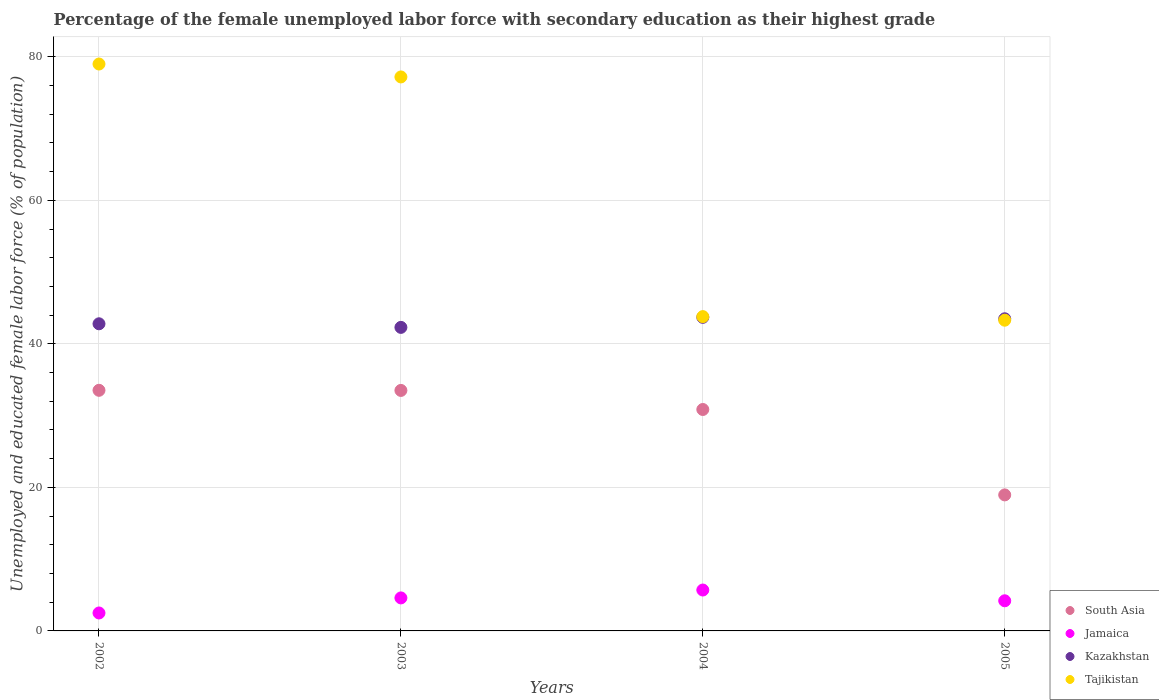How many different coloured dotlines are there?
Your response must be concise. 4. What is the percentage of the unemployed female labor force with secondary education in South Asia in 2003?
Offer a terse response. 33.51. Across all years, what is the maximum percentage of the unemployed female labor force with secondary education in Kazakhstan?
Make the answer very short. 43.7. Across all years, what is the minimum percentage of the unemployed female labor force with secondary education in Tajikistan?
Provide a succinct answer. 43.3. In which year was the percentage of the unemployed female labor force with secondary education in Kazakhstan maximum?
Offer a very short reply. 2004. In which year was the percentage of the unemployed female labor force with secondary education in Tajikistan minimum?
Give a very brief answer. 2005. What is the total percentage of the unemployed female labor force with secondary education in Tajikistan in the graph?
Your answer should be compact. 243.3. What is the difference between the percentage of the unemployed female labor force with secondary education in Jamaica in 2004 and the percentage of the unemployed female labor force with secondary education in Tajikistan in 2005?
Your response must be concise. -37.6. What is the average percentage of the unemployed female labor force with secondary education in Kazakhstan per year?
Your response must be concise. 43.07. In the year 2002, what is the difference between the percentage of the unemployed female labor force with secondary education in South Asia and percentage of the unemployed female labor force with secondary education in Jamaica?
Keep it short and to the point. 31.03. What is the ratio of the percentage of the unemployed female labor force with secondary education in South Asia in 2002 to that in 2004?
Keep it short and to the point. 1.09. What is the difference between the highest and the second highest percentage of the unemployed female labor force with secondary education in Kazakhstan?
Offer a very short reply. 0.2. What is the difference between the highest and the lowest percentage of the unemployed female labor force with secondary education in Tajikistan?
Offer a terse response. 35.7. In how many years, is the percentage of the unemployed female labor force with secondary education in South Asia greater than the average percentage of the unemployed female labor force with secondary education in South Asia taken over all years?
Give a very brief answer. 3. Is it the case that in every year, the sum of the percentage of the unemployed female labor force with secondary education in Tajikistan and percentage of the unemployed female labor force with secondary education in Jamaica  is greater than the sum of percentage of the unemployed female labor force with secondary education in Kazakhstan and percentage of the unemployed female labor force with secondary education in South Asia?
Give a very brief answer. Yes. Is it the case that in every year, the sum of the percentage of the unemployed female labor force with secondary education in Jamaica and percentage of the unemployed female labor force with secondary education in South Asia  is greater than the percentage of the unemployed female labor force with secondary education in Kazakhstan?
Make the answer very short. No. Does the percentage of the unemployed female labor force with secondary education in Jamaica monotonically increase over the years?
Keep it short and to the point. No. How many years are there in the graph?
Provide a short and direct response. 4. Are the values on the major ticks of Y-axis written in scientific E-notation?
Provide a short and direct response. No. How are the legend labels stacked?
Provide a succinct answer. Vertical. What is the title of the graph?
Make the answer very short. Percentage of the female unemployed labor force with secondary education as their highest grade. What is the label or title of the X-axis?
Your answer should be very brief. Years. What is the label or title of the Y-axis?
Make the answer very short. Unemployed and educated female labor force (% of population). What is the Unemployed and educated female labor force (% of population) in South Asia in 2002?
Provide a succinct answer. 33.53. What is the Unemployed and educated female labor force (% of population) in Jamaica in 2002?
Your response must be concise. 2.5. What is the Unemployed and educated female labor force (% of population) of Kazakhstan in 2002?
Keep it short and to the point. 42.8. What is the Unemployed and educated female labor force (% of population) of Tajikistan in 2002?
Your answer should be very brief. 79. What is the Unemployed and educated female labor force (% of population) of South Asia in 2003?
Keep it short and to the point. 33.51. What is the Unemployed and educated female labor force (% of population) in Jamaica in 2003?
Give a very brief answer. 4.6. What is the Unemployed and educated female labor force (% of population) in Kazakhstan in 2003?
Provide a succinct answer. 42.3. What is the Unemployed and educated female labor force (% of population) of Tajikistan in 2003?
Offer a very short reply. 77.2. What is the Unemployed and educated female labor force (% of population) in South Asia in 2004?
Ensure brevity in your answer.  30.86. What is the Unemployed and educated female labor force (% of population) in Jamaica in 2004?
Offer a terse response. 5.7. What is the Unemployed and educated female labor force (% of population) of Kazakhstan in 2004?
Your answer should be very brief. 43.7. What is the Unemployed and educated female labor force (% of population) of Tajikistan in 2004?
Your answer should be compact. 43.8. What is the Unemployed and educated female labor force (% of population) of South Asia in 2005?
Provide a short and direct response. 18.96. What is the Unemployed and educated female labor force (% of population) in Jamaica in 2005?
Give a very brief answer. 4.2. What is the Unemployed and educated female labor force (% of population) in Kazakhstan in 2005?
Offer a terse response. 43.5. What is the Unemployed and educated female labor force (% of population) of Tajikistan in 2005?
Your answer should be very brief. 43.3. Across all years, what is the maximum Unemployed and educated female labor force (% of population) in South Asia?
Your response must be concise. 33.53. Across all years, what is the maximum Unemployed and educated female labor force (% of population) in Jamaica?
Offer a terse response. 5.7. Across all years, what is the maximum Unemployed and educated female labor force (% of population) in Kazakhstan?
Provide a short and direct response. 43.7. Across all years, what is the maximum Unemployed and educated female labor force (% of population) in Tajikistan?
Keep it short and to the point. 79. Across all years, what is the minimum Unemployed and educated female labor force (% of population) of South Asia?
Offer a terse response. 18.96. Across all years, what is the minimum Unemployed and educated female labor force (% of population) in Kazakhstan?
Make the answer very short. 42.3. Across all years, what is the minimum Unemployed and educated female labor force (% of population) in Tajikistan?
Provide a succinct answer. 43.3. What is the total Unemployed and educated female labor force (% of population) of South Asia in the graph?
Provide a short and direct response. 116.86. What is the total Unemployed and educated female labor force (% of population) of Kazakhstan in the graph?
Provide a succinct answer. 172.3. What is the total Unemployed and educated female labor force (% of population) of Tajikistan in the graph?
Provide a succinct answer. 243.3. What is the difference between the Unemployed and educated female labor force (% of population) in South Asia in 2002 and that in 2003?
Offer a terse response. 0.02. What is the difference between the Unemployed and educated female labor force (% of population) in Jamaica in 2002 and that in 2003?
Your answer should be very brief. -2.1. What is the difference between the Unemployed and educated female labor force (% of population) in South Asia in 2002 and that in 2004?
Provide a succinct answer. 2.67. What is the difference between the Unemployed and educated female labor force (% of population) in Kazakhstan in 2002 and that in 2004?
Your answer should be compact. -0.9. What is the difference between the Unemployed and educated female labor force (% of population) in Tajikistan in 2002 and that in 2004?
Keep it short and to the point. 35.2. What is the difference between the Unemployed and educated female labor force (% of population) in South Asia in 2002 and that in 2005?
Your response must be concise. 14.58. What is the difference between the Unemployed and educated female labor force (% of population) in Jamaica in 2002 and that in 2005?
Your response must be concise. -1.7. What is the difference between the Unemployed and educated female labor force (% of population) of Tajikistan in 2002 and that in 2005?
Provide a succinct answer. 35.7. What is the difference between the Unemployed and educated female labor force (% of population) of South Asia in 2003 and that in 2004?
Your response must be concise. 2.66. What is the difference between the Unemployed and educated female labor force (% of population) of Tajikistan in 2003 and that in 2004?
Provide a succinct answer. 33.4. What is the difference between the Unemployed and educated female labor force (% of population) in South Asia in 2003 and that in 2005?
Your response must be concise. 14.56. What is the difference between the Unemployed and educated female labor force (% of population) of Jamaica in 2003 and that in 2005?
Your response must be concise. 0.4. What is the difference between the Unemployed and educated female labor force (% of population) of Tajikistan in 2003 and that in 2005?
Offer a terse response. 33.9. What is the difference between the Unemployed and educated female labor force (% of population) of South Asia in 2004 and that in 2005?
Your answer should be compact. 11.9. What is the difference between the Unemployed and educated female labor force (% of population) of Jamaica in 2004 and that in 2005?
Keep it short and to the point. 1.5. What is the difference between the Unemployed and educated female labor force (% of population) in Kazakhstan in 2004 and that in 2005?
Your response must be concise. 0.2. What is the difference between the Unemployed and educated female labor force (% of population) of South Asia in 2002 and the Unemployed and educated female labor force (% of population) of Jamaica in 2003?
Ensure brevity in your answer.  28.93. What is the difference between the Unemployed and educated female labor force (% of population) of South Asia in 2002 and the Unemployed and educated female labor force (% of population) of Kazakhstan in 2003?
Ensure brevity in your answer.  -8.77. What is the difference between the Unemployed and educated female labor force (% of population) of South Asia in 2002 and the Unemployed and educated female labor force (% of population) of Tajikistan in 2003?
Provide a succinct answer. -43.67. What is the difference between the Unemployed and educated female labor force (% of population) in Jamaica in 2002 and the Unemployed and educated female labor force (% of population) in Kazakhstan in 2003?
Your response must be concise. -39.8. What is the difference between the Unemployed and educated female labor force (% of population) in Jamaica in 2002 and the Unemployed and educated female labor force (% of population) in Tajikistan in 2003?
Your answer should be compact. -74.7. What is the difference between the Unemployed and educated female labor force (% of population) of Kazakhstan in 2002 and the Unemployed and educated female labor force (% of population) of Tajikistan in 2003?
Ensure brevity in your answer.  -34.4. What is the difference between the Unemployed and educated female labor force (% of population) in South Asia in 2002 and the Unemployed and educated female labor force (% of population) in Jamaica in 2004?
Your answer should be compact. 27.83. What is the difference between the Unemployed and educated female labor force (% of population) of South Asia in 2002 and the Unemployed and educated female labor force (% of population) of Kazakhstan in 2004?
Your answer should be compact. -10.17. What is the difference between the Unemployed and educated female labor force (% of population) of South Asia in 2002 and the Unemployed and educated female labor force (% of population) of Tajikistan in 2004?
Ensure brevity in your answer.  -10.27. What is the difference between the Unemployed and educated female labor force (% of population) in Jamaica in 2002 and the Unemployed and educated female labor force (% of population) in Kazakhstan in 2004?
Offer a very short reply. -41.2. What is the difference between the Unemployed and educated female labor force (% of population) of Jamaica in 2002 and the Unemployed and educated female labor force (% of population) of Tajikistan in 2004?
Offer a very short reply. -41.3. What is the difference between the Unemployed and educated female labor force (% of population) in South Asia in 2002 and the Unemployed and educated female labor force (% of population) in Jamaica in 2005?
Make the answer very short. 29.33. What is the difference between the Unemployed and educated female labor force (% of population) in South Asia in 2002 and the Unemployed and educated female labor force (% of population) in Kazakhstan in 2005?
Your response must be concise. -9.97. What is the difference between the Unemployed and educated female labor force (% of population) of South Asia in 2002 and the Unemployed and educated female labor force (% of population) of Tajikistan in 2005?
Your answer should be very brief. -9.77. What is the difference between the Unemployed and educated female labor force (% of population) in Jamaica in 2002 and the Unemployed and educated female labor force (% of population) in Kazakhstan in 2005?
Your answer should be compact. -41. What is the difference between the Unemployed and educated female labor force (% of population) in Jamaica in 2002 and the Unemployed and educated female labor force (% of population) in Tajikistan in 2005?
Offer a terse response. -40.8. What is the difference between the Unemployed and educated female labor force (% of population) of Kazakhstan in 2002 and the Unemployed and educated female labor force (% of population) of Tajikistan in 2005?
Your answer should be compact. -0.5. What is the difference between the Unemployed and educated female labor force (% of population) in South Asia in 2003 and the Unemployed and educated female labor force (% of population) in Jamaica in 2004?
Provide a succinct answer. 27.81. What is the difference between the Unemployed and educated female labor force (% of population) of South Asia in 2003 and the Unemployed and educated female labor force (% of population) of Kazakhstan in 2004?
Keep it short and to the point. -10.19. What is the difference between the Unemployed and educated female labor force (% of population) of South Asia in 2003 and the Unemployed and educated female labor force (% of population) of Tajikistan in 2004?
Your response must be concise. -10.29. What is the difference between the Unemployed and educated female labor force (% of population) of Jamaica in 2003 and the Unemployed and educated female labor force (% of population) of Kazakhstan in 2004?
Provide a succinct answer. -39.1. What is the difference between the Unemployed and educated female labor force (% of population) of Jamaica in 2003 and the Unemployed and educated female labor force (% of population) of Tajikistan in 2004?
Give a very brief answer. -39.2. What is the difference between the Unemployed and educated female labor force (% of population) in Kazakhstan in 2003 and the Unemployed and educated female labor force (% of population) in Tajikistan in 2004?
Your answer should be compact. -1.5. What is the difference between the Unemployed and educated female labor force (% of population) in South Asia in 2003 and the Unemployed and educated female labor force (% of population) in Jamaica in 2005?
Provide a succinct answer. 29.31. What is the difference between the Unemployed and educated female labor force (% of population) of South Asia in 2003 and the Unemployed and educated female labor force (% of population) of Kazakhstan in 2005?
Make the answer very short. -9.99. What is the difference between the Unemployed and educated female labor force (% of population) of South Asia in 2003 and the Unemployed and educated female labor force (% of population) of Tajikistan in 2005?
Offer a very short reply. -9.79. What is the difference between the Unemployed and educated female labor force (% of population) of Jamaica in 2003 and the Unemployed and educated female labor force (% of population) of Kazakhstan in 2005?
Offer a terse response. -38.9. What is the difference between the Unemployed and educated female labor force (% of population) of Jamaica in 2003 and the Unemployed and educated female labor force (% of population) of Tajikistan in 2005?
Offer a terse response. -38.7. What is the difference between the Unemployed and educated female labor force (% of population) of Kazakhstan in 2003 and the Unemployed and educated female labor force (% of population) of Tajikistan in 2005?
Your answer should be compact. -1. What is the difference between the Unemployed and educated female labor force (% of population) in South Asia in 2004 and the Unemployed and educated female labor force (% of population) in Jamaica in 2005?
Make the answer very short. 26.66. What is the difference between the Unemployed and educated female labor force (% of population) of South Asia in 2004 and the Unemployed and educated female labor force (% of population) of Kazakhstan in 2005?
Provide a succinct answer. -12.64. What is the difference between the Unemployed and educated female labor force (% of population) in South Asia in 2004 and the Unemployed and educated female labor force (% of population) in Tajikistan in 2005?
Your answer should be very brief. -12.44. What is the difference between the Unemployed and educated female labor force (% of population) of Jamaica in 2004 and the Unemployed and educated female labor force (% of population) of Kazakhstan in 2005?
Provide a short and direct response. -37.8. What is the difference between the Unemployed and educated female labor force (% of population) in Jamaica in 2004 and the Unemployed and educated female labor force (% of population) in Tajikistan in 2005?
Keep it short and to the point. -37.6. What is the average Unemployed and educated female labor force (% of population) in South Asia per year?
Offer a very short reply. 29.21. What is the average Unemployed and educated female labor force (% of population) in Jamaica per year?
Ensure brevity in your answer.  4.25. What is the average Unemployed and educated female labor force (% of population) of Kazakhstan per year?
Offer a very short reply. 43.08. What is the average Unemployed and educated female labor force (% of population) in Tajikistan per year?
Offer a terse response. 60.83. In the year 2002, what is the difference between the Unemployed and educated female labor force (% of population) in South Asia and Unemployed and educated female labor force (% of population) in Jamaica?
Give a very brief answer. 31.03. In the year 2002, what is the difference between the Unemployed and educated female labor force (% of population) in South Asia and Unemployed and educated female labor force (% of population) in Kazakhstan?
Keep it short and to the point. -9.27. In the year 2002, what is the difference between the Unemployed and educated female labor force (% of population) of South Asia and Unemployed and educated female labor force (% of population) of Tajikistan?
Offer a terse response. -45.47. In the year 2002, what is the difference between the Unemployed and educated female labor force (% of population) in Jamaica and Unemployed and educated female labor force (% of population) in Kazakhstan?
Ensure brevity in your answer.  -40.3. In the year 2002, what is the difference between the Unemployed and educated female labor force (% of population) in Jamaica and Unemployed and educated female labor force (% of population) in Tajikistan?
Your answer should be compact. -76.5. In the year 2002, what is the difference between the Unemployed and educated female labor force (% of population) of Kazakhstan and Unemployed and educated female labor force (% of population) of Tajikistan?
Ensure brevity in your answer.  -36.2. In the year 2003, what is the difference between the Unemployed and educated female labor force (% of population) of South Asia and Unemployed and educated female labor force (% of population) of Jamaica?
Offer a very short reply. 28.91. In the year 2003, what is the difference between the Unemployed and educated female labor force (% of population) of South Asia and Unemployed and educated female labor force (% of population) of Kazakhstan?
Your response must be concise. -8.79. In the year 2003, what is the difference between the Unemployed and educated female labor force (% of population) in South Asia and Unemployed and educated female labor force (% of population) in Tajikistan?
Provide a short and direct response. -43.69. In the year 2003, what is the difference between the Unemployed and educated female labor force (% of population) of Jamaica and Unemployed and educated female labor force (% of population) of Kazakhstan?
Ensure brevity in your answer.  -37.7. In the year 2003, what is the difference between the Unemployed and educated female labor force (% of population) in Jamaica and Unemployed and educated female labor force (% of population) in Tajikistan?
Give a very brief answer. -72.6. In the year 2003, what is the difference between the Unemployed and educated female labor force (% of population) of Kazakhstan and Unemployed and educated female labor force (% of population) of Tajikistan?
Keep it short and to the point. -34.9. In the year 2004, what is the difference between the Unemployed and educated female labor force (% of population) in South Asia and Unemployed and educated female labor force (% of population) in Jamaica?
Provide a succinct answer. 25.16. In the year 2004, what is the difference between the Unemployed and educated female labor force (% of population) of South Asia and Unemployed and educated female labor force (% of population) of Kazakhstan?
Provide a succinct answer. -12.84. In the year 2004, what is the difference between the Unemployed and educated female labor force (% of population) of South Asia and Unemployed and educated female labor force (% of population) of Tajikistan?
Provide a succinct answer. -12.94. In the year 2004, what is the difference between the Unemployed and educated female labor force (% of population) in Jamaica and Unemployed and educated female labor force (% of population) in Kazakhstan?
Your response must be concise. -38. In the year 2004, what is the difference between the Unemployed and educated female labor force (% of population) of Jamaica and Unemployed and educated female labor force (% of population) of Tajikistan?
Provide a succinct answer. -38.1. In the year 2005, what is the difference between the Unemployed and educated female labor force (% of population) in South Asia and Unemployed and educated female labor force (% of population) in Jamaica?
Your answer should be very brief. 14.76. In the year 2005, what is the difference between the Unemployed and educated female labor force (% of population) of South Asia and Unemployed and educated female labor force (% of population) of Kazakhstan?
Give a very brief answer. -24.54. In the year 2005, what is the difference between the Unemployed and educated female labor force (% of population) in South Asia and Unemployed and educated female labor force (% of population) in Tajikistan?
Provide a succinct answer. -24.34. In the year 2005, what is the difference between the Unemployed and educated female labor force (% of population) of Jamaica and Unemployed and educated female labor force (% of population) of Kazakhstan?
Your answer should be compact. -39.3. In the year 2005, what is the difference between the Unemployed and educated female labor force (% of population) of Jamaica and Unemployed and educated female labor force (% of population) of Tajikistan?
Provide a succinct answer. -39.1. What is the ratio of the Unemployed and educated female labor force (% of population) of Jamaica in 2002 to that in 2003?
Offer a terse response. 0.54. What is the ratio of the Unemployed and educated female labor force (% of population) in Kazakhstan in 2002 to that in 2003?
Your answer should be very brief. 1.01. What is the ratio of the Unemployed and educated female labor force (% of population) of Tajikistan in 2002 to that in 2003?
Your answer should be compact. 1.02. What is the ratio of the Unemployed and educated female labor force (% of population) in South Asia in 2002 to that in 2004?
Provide a short and direct response. 1.09. What is the ratio of the Unemployed and educated female labor force (% of population) in Jamaica in 2002 to that in 2004?
Keep it short and to the point. 0.44. What is the ratio of the Unemployed and educated female labor force (% of population) of Kazakhstan in 2002 to that in 2004?
Your answer should be compact. 0.98. What is the ratio of the Unemployed and educated female labor force (% of population) of Tajikistan in 2002 to that in 2004?
Your answer should be very brief. 1.8. What is the ratio of the Unemployed and educated female labor force (% of population) of South Asia in 2002 to that in 2005?
Offer a terse response. 1.77. What is the ratio of the Unemployed and educated female labor force (% of population) in Jamaica in 2002 to that in 2005?
Provide a succinct answer. 0.6. What is the ratio of the Unemployed and educated female labor force (% of population) in Kazakhstan in 2002 to that in 2005?
Provide a succinct answer. 0.98. What is the ratio of the Unemployed and educated female labor force (% of population) of Tajikistan in 2002 to that in 2005?
Offer a very short reply. 1.82. What is the ratio of the Unemployed and educated female labor force (% of population) in South Asia in 2003 to that in 2004?
Make the answer very short. 1.09. What is the ratio of the Unemployed and educated female labor force (% of population) in Jamaica in 2003 to that in 2004?
Give a very brief answer. 0.81. What is the ratio of the Unemployed and educated female labor force (% of population) of Tajikistan in 2003 to that in 2004?
Offer a very short reply. 1.76. What is the ratio of the Unemployed and educated female labor force (% of population) in South Asia in 2003 to that in 2005?
Your answer should be compact. 1.77. What is the ratio of the Unemployed and educated female labor force (% of population) of Jamaica in 2003 to that in 2005?
Your response must be concise. 1.1. What is the ratio of the Unemployed and educated female labor force (% of population) of Kazakhstan in 2003 to that in 2005?
Offer a terse response. 0.97. What is the ratio of the Unemployed and educated female labor force (% of population) in Tajikistan in 2003 to that in 2005?
Ensure brevity in your answer.  1.78. What is the ratio of the Unemployed and educated female labor force (% of population) of South Asia in 2004 to that in 2005?
Offer a terse response. 1.63. What is the ratio of the Unemployed and educated female labor force (% of population) of Jamaica in 2004 to that in 2005?
Make the answer very short. 1.36. What is the ratio of the Unemployed and educated female labor force (% of population) of Kazakhstan in 2004 to that in 2005?
Keep it short and to the point. 1. What is the ratio of the Unemployed and educated female labor force (% of population) in Tajikistan in 2004 to that in 2005?
Your response must be concise. 1.01. What is the difference between the highest and the second highest Unemployed and educated female labor force (% of population) of South Asia?
Provide a short and direct response. 0.02. What is the difference between the highest and the second highest Unemployed and educated female labor force (% of population) in Kazakhstan?
Offer a terse response. 0.2. What is the difference between the highest and the second highest Unemployed and educated female labor force (% of population) in Tajikistan?
Give a very brief answer. 1.8. What is the difference between the highest and the lowest Unemployed and educated female labor force (% of population) of South Asia?
Provide a short and direct response. 14.58. What is the difference between the highest and the lowest Unemployed and educated female labor force (% of population) in Tajikistan?
Offer a very short reply. 35.7. 